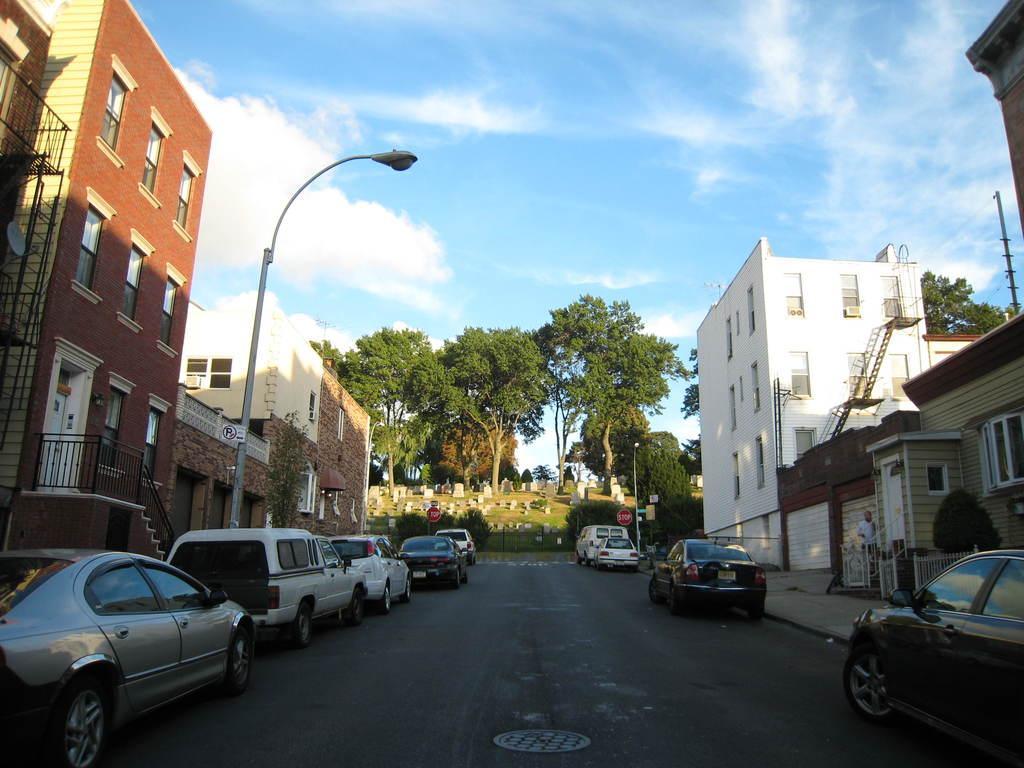Can you describe this image briefly? Here we can see vehicles on the road. There are buildings to either side of the road,windows,fences,doors,street lights,poles,plants and some other objects. In the background there are trees,graveyard,grass and clouds in the sky. On the right a man is standing and another person is standing at the graveyard. 